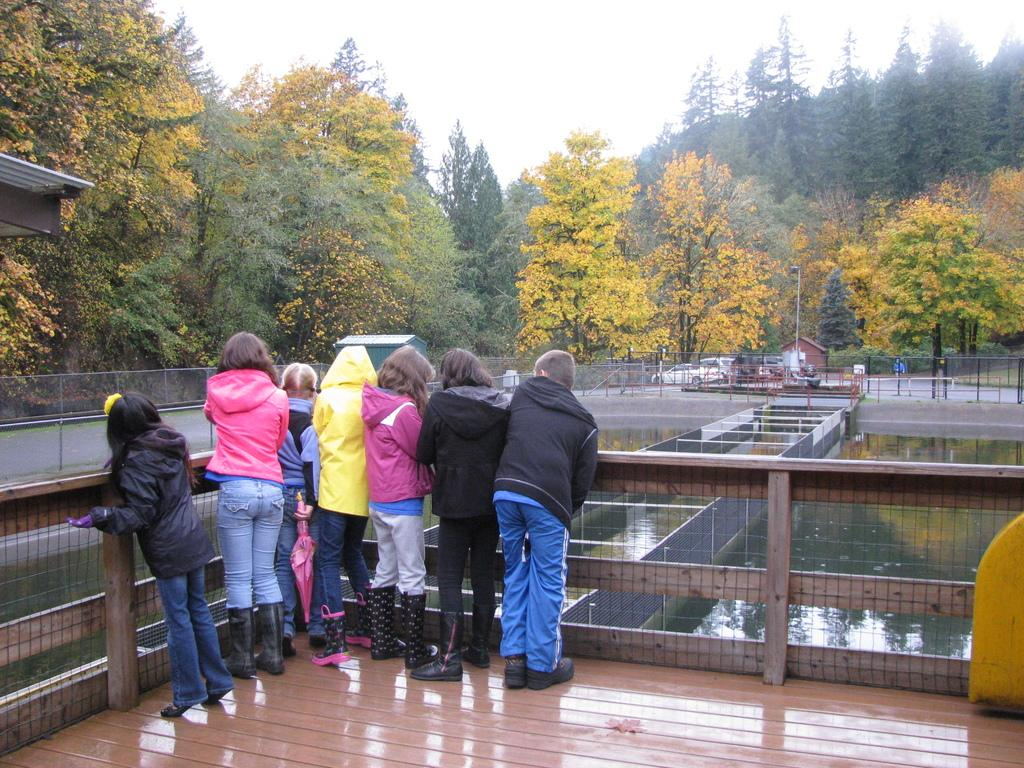What is the main subject in the middle of the image? There is a group of children in the middle of the image. What can be seen on the right side of the image? There is water on the right side of the image. What is visible in the background of the image? There are vehicles and trees visible in the background of the image. What is visible at the top of the image? The sky is visible at the top of the image. What type of key is being used to unlock the plantation in the image? There is no key or plantation present in the image. What role does the lead play in the image? There is no lead or specific role mentioned in the image; it features a group of children, water, vehicles, trees, and the sky. 